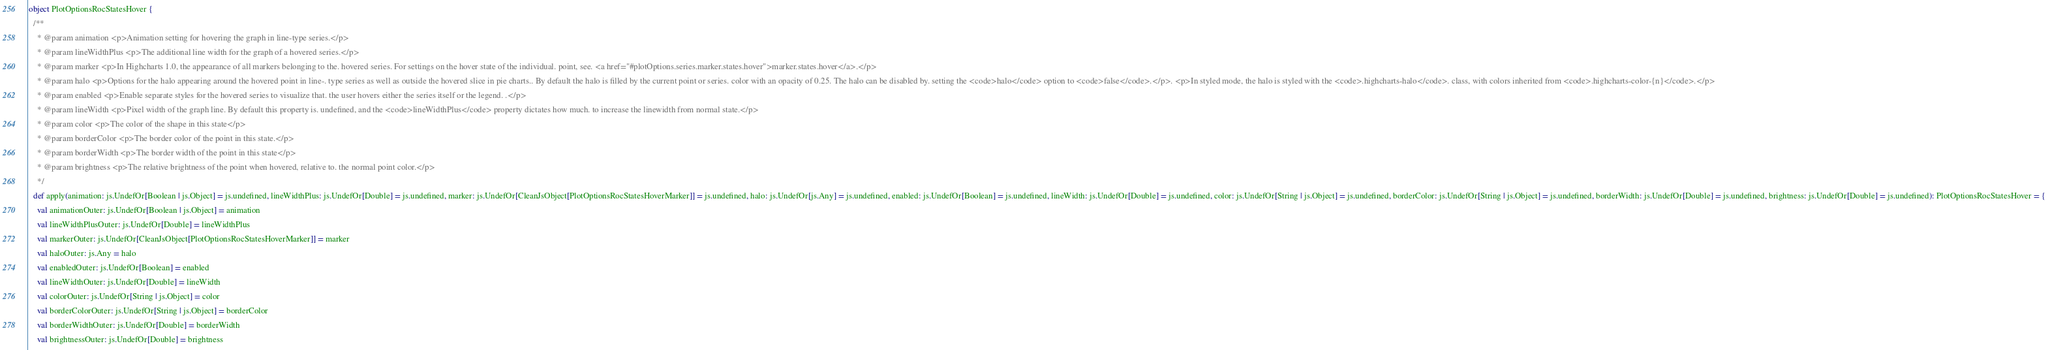Convert code to text. <code><loc_0><loc_0><loc_500><loc_500><_Scala_>
object PlotOptionsRocStatesHover {
  /**
    * @param animation <p>Animation setting for hovering the graph in line-type series.</p>
    * @param lineWidthPlus <p>The additional line width for the graph of a hovered series.</p>
    * @param marker <p>In Highcharts 1.0, the appearance of all markers belonging to the. hovered series. For settings on the hover state of the individual. point, see. <a href="#plotOptions.series.marker.states.hover">marker.states.hover</a>.</p>
    * @param halo <p>Options for the halo appearing around the hovered point in line-. type series as well as outside the hovered slice in pie charts.. By default the halo is filled by the current point or series. color with an opacity of 0.25. The halo can be disabled by. setting the <code>halo</code> option to <code>false</code>.</p>. <p>In styled mode, the halo is styled with the <code>.highcharts-halo</code>. class, with colors inherited from <code>.highcharts-color-{n}</code>.</p>
    * @param enabled <p>Enable separate styles for the hovered series to visualize that. the user hovers either the series itself or the legend. .</p>
    * @param lineWidth <p>Pixel width of the graph line. By default this property is. undefined, and the <code>lineWidthPlus</code> property dictates how much. to increase the linewidth from normal state.</p>
    * @param color <p>The color of the shape in this state</p>
    * @param borderColor <p>The border color of the point in this state.</p>
    * @param borderWidth <p>The border width of the point in this state</p>
    * @param brightness <p>The relative brightness of the point when hovered, relative to. the normal point color.</p>
    */
  def apply(animation: js.UndefOr[Boolean | js.Object] = js.undefined, lineWidthPlus: js.UndefOr[Double] = js.undefined, marker: js.UndefOr[CleanJsObject[PlotOptionsRocStatesHoverMarker]] = js.undefined, halo: js.UndefOr[js.Any] = js.undefined, enabled: js.UndefOr[Boolean] = js.undefined, lineWidth: js.UndefOr[Double] = js.undefined, color: js.UndefOr[String | js.Object] = js.undefined, borderColor: js.UndefOr[String | js.Object] = js.undefined, borderWidth: js.UndefOr[Double] = js.undefined, brightness: js.UndefOr[Double] = js.undefined): PlotOptionsRocStatesHover = {
    val animationOuter: js.UndefOr[Boolean | js.Object] = animation
    val lineWidthPlusOuter: js.UndefOr[Double] = lineWidthPlus
    val markerOuter: js.UndefOr[CleanJsObject[PlotOptionsRocStatesHoverMarker]] = marker
    val haloOuter: js.Any = halo
    val enabledOuter: js.UndefOr[Boolean] = enabled
    val lineWidthOuter: js.UndefOr[Double] = lineWidth
    val colorOuter: js.UndefOr[String | js.Object] = color
    val borderColorOuter: js.UndefOr[String | js.Object] = borderColor
    val borderWidthOuter: js.UndefOr[Double] = borderWidth
    val brightnessOuter: js.UndefOr[Double] = brightness</code> 